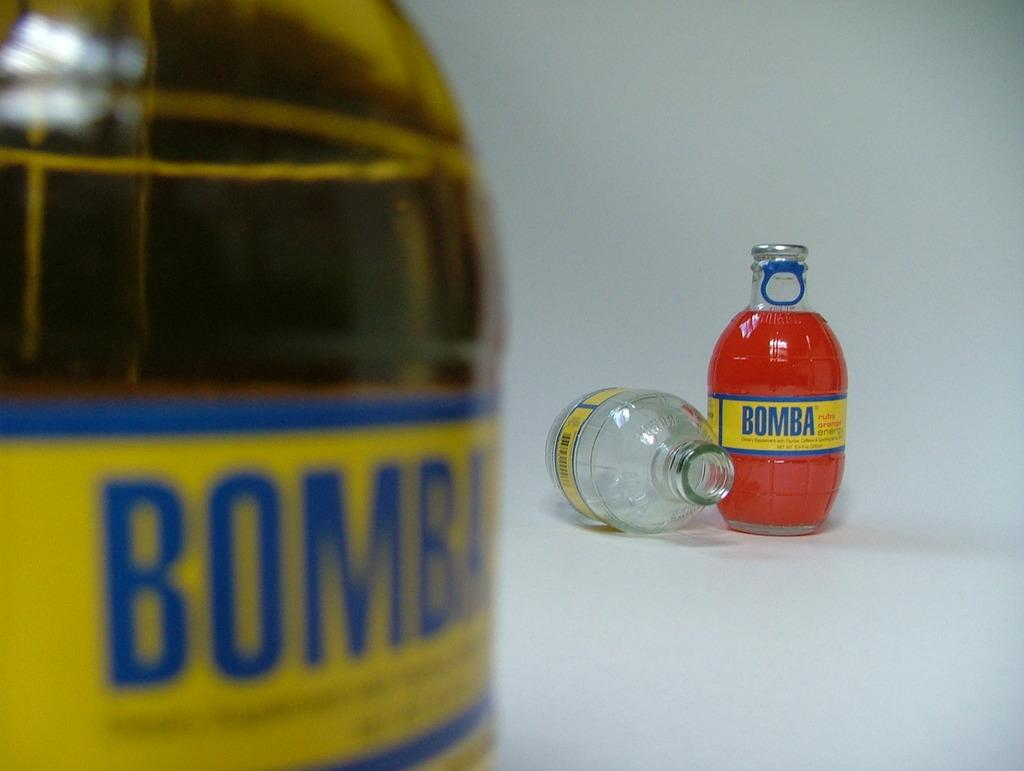<image>
Relay a brief, clear account of the picture shown. The word Bomba is visible on some bottles in view. 